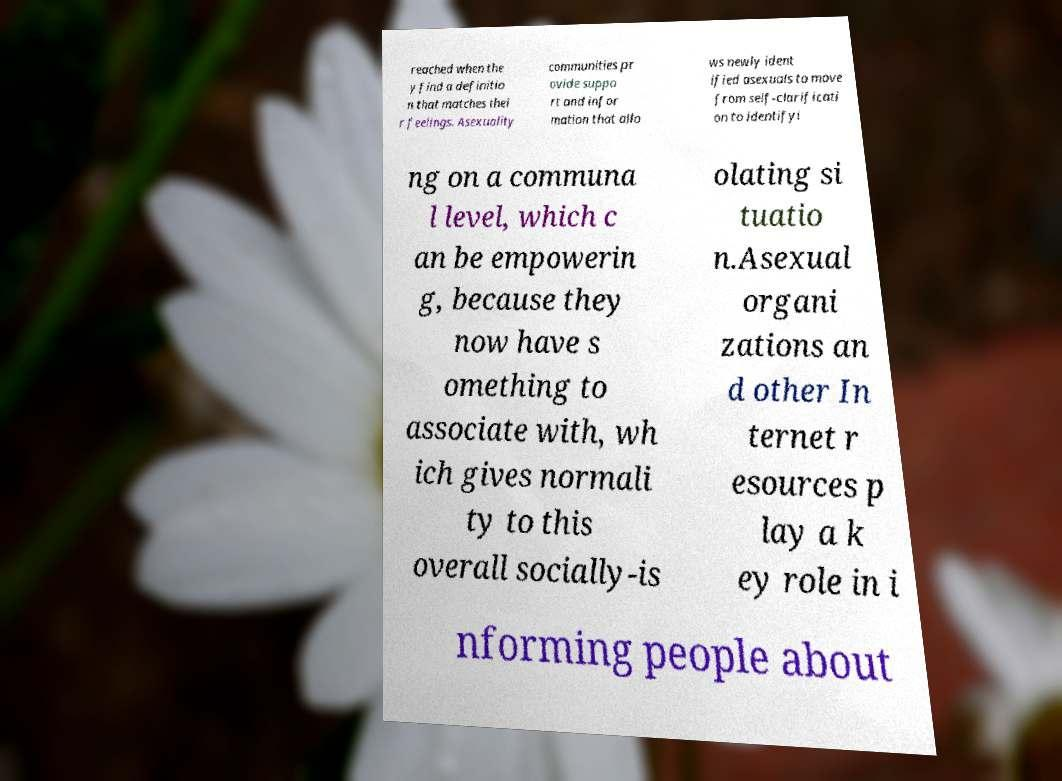Please read and relay the text visible in this image. What does it say? reached when the y find a definitio n that matches thei r feelings. Asexuality communities pr ovide suppo rt and infor mation that allo ws newly ident ified asexuals to move from self-clarificati on to identifyi ng on a communa l level, which c an be empowerin g, because they now have s omething to associate with, wh ich gives normali ty to this overall socially-is olating si tuatio n.Asexual organi zations an d other In ternet r esources p lay a k ey role in i nforming people about 